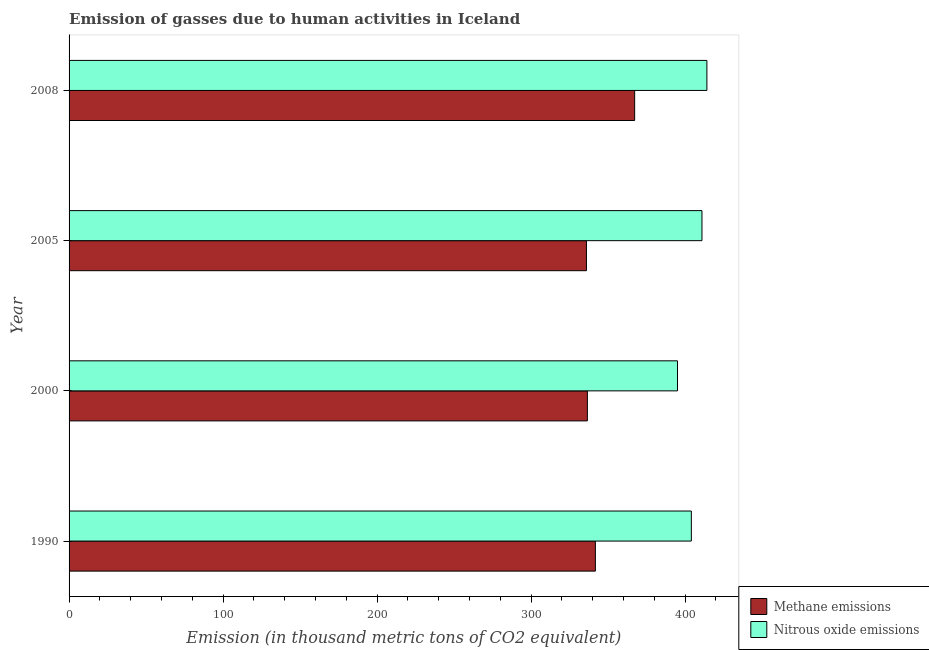Are the number of bars per tick equal to the number of legend labels?
Your answer should be very brief. Yes. Are the number of bars on each tick of the Y-axis equal?
Provide a short and direct response. Yes. How many bars are there on the 4th tick from the top?
Keep it short and to the point. 2. How many bars are there on the 3rd tick from the bottom?
Provide a short and direct response. 2. In how many cases, is the number of bars for a given year not equal to the number of legend labels?
Provide a succinct answer. 0. What is the amount of methane emissions in 1990?
Provide a succinct answer. 341.7. Across all years, what is the maximum amount of nitrous oxide emissions?
Ensure brevity in your answer.  414.1. Across all years, what is the minimum amount of methane emissions?
Offer a terse response. 335.9. In which year was the amount of methane emissions minimum?
Your response must be concise. 2005. What is the total amount of nitrous oxide emissions in the graph?
Keep it short and to the point. 1624. What is the difference between the amount of nitrous oxide emissions in 1990 and that in 2008?
Give a very brief answer. -10.1. What is the difference between the amount of methane emissions in 2000 and the amount of nitrous oxide emissions in 1990?
Ensure brevity in your answer.  -67.5. What is the average amount of nitrous oxide emissions per year?
Provide a succinct answer. 406. In the year 2005, what is the difference between the amount of nitrous oxide emissions and amount of methane emissions?
Give a very brief answer. 75. What is the ratio of the amount of methane emissions in 2000 to that in 2005?
Give a very brief answer. 1. Is the amount of methane emissions in 2005 less than that in 2008?
Make the answer very short. Yes. Is the difference between the amount of nitrous oxide emissions in 2000 and 2008 greater than the difference between the amount of methane emissions in 2000 and 2008?
Your response must be concise. Yes. What is the difference between the highest and the lowest amount of nitrous oxide emissions?
Your response must be concise. 19.1. What does the 1st bar from the top in 2005 represents?
Make the answer very short. Nitrous oxide emissions. What does the 2nd bar from the bottom in 2005 represents?
Make the answer very short. Nitrous oxide emissions. How many years are there in the graph?
Your answer should be very brief. 4. Are the values on the major ticks of X-axis written in scientific E-notation?
Your answer should be compact. No. Does the graph contain any zero values?
Keep it short and to the point. No. What is the title of the graph?
Make the answer very short. Emission of gasses due to human activities in Iceland. Does "Private credit bureau" appear as one of the legend labels in the graph?
Offer a very short reply. No. What is the label or title of the X-axis?
Your answer should be compact. Emission (in thousand metric tons of CO2 equivalent). What is the Emission (in thousand metric tons of CO2 equivalent) of Methane emissions in 1990?
Provide a short and direct response. 341.7. What is the Emission (in thousand metric tons of CO2 equivalent) of Nitrous oxide emissions in 1990?
Provide a succinct answer. 404. What is the Emission (in thousand metric tons of CO2 equivalent) of Methane emissions in 2000?
Keep it short and to the point. 336.5. What is the Emission (in thousand metric tons of CO2 equivalent) in Nitrous oxide emissions in 2000?
Ensure brevity in your answer.  395. What is the Emission (in thousand metric tons of CO2 equivalent) of Methane emissions in 2005?
Ensure brevity in your answer.  335.9. What is the Emission (in thousand metric tons of CO2 equivalent) in Nitrous oxide emissions in 2005?
Make the answer very short. 410.9. What is the Emission (in thousand metric tons of CO2 equivalent) in Methane emissions in 2008?
Provide a short and direct response. 367.2. What is the Emission (in thousand metric tons of CO2 equivalent) of Nitrous oxide emissions in 2008?
Provide a succinct answer. 414.1. Across all years, what is the maximum Emission (in thousand metric tons of CO2 equivalent) in Methane emissions?
Offer a very short reply. 367.2. Across all years, what is the maximum Emission (in thousand metric tons of CO2 equivalent) of Nitrous oxide emissions?
Your response must be concise. 414.1. Across all years, what is the minimum Emission (in thousand metric tons of CO2 equivalent) of Methane emissions?
Make the answer very short. 335.9. Across all years, what is the minimum Emission (in thousand metric tons of CO2 equivalent) of Nitrous oxide emissions?
Offer a very short reply. 395. What is the total Emission (in thousand metric tons of CO2 equivalent) in Methane emissions in the graph?
Your answer should be very brief. 1381.3. What is the total Emission (in thousand metric tons of CO2 equivalent) in Nitrous oxide emissions in the graph?
Keep it short and to the point. 1624. What is the difference between the Emission (in thousand metric tons of CO2 equivalent) in Nitrous oxide emissions in 1990 and that in 2000?
Offer a very short reply. 9. What is the difference between the Emission (in thousand metric tons of CO2 equivalent) of Methane emissions in 1990 and that in 2008?
Ensure brevity in your answer.  -25.5. What is the difference between the Emission (in thousand metric tons of CO2 equivalent) of Nitrous oxide emissions in 1990 and that in 2008?
Offer a very short reply. -10.1. What is the difference between the Emission (in thousand metric tons of CO2 equivalent) in Methane emissions in 2000 and that in 2005?
Your answer should be very brief. 0.6. What is the difference between the Emission (in thousand metric tons of CO2 equivalent) of Nitrous oxide emissions in 2000 and that in 2005?
Offer a very short reply. -15.9. What is the difference between the Emission (in thousand metric tons of CO2 equivalent) in Methane emissions in 2000 and that in 2008?
Provide a short and direct response. -30.7. What is the difference between the Emission (in thousand metric tons of CO2 equivalent) in Nitrous oxide emissions in 2000 and that in 2008?
Provide a succinct answer. -19.1. What is the difference between the Emission (in thousand metric tons of CO2 equivalent) in Methane emissions in 2005 and that in 2008?
Offer a terse response. -31.3. What is the difference between the Emission (in thousand metric tons of CO2 equivalent) in Methane emissions in 1990 and the Emission (in thousand metric tons of CO2 equivalent) in Nitrous oxide emissions in 2000?
Offer a terse response. -53.3. What is the difference between the Emission (in thousand metric tons of CO2 equivalent) of Methane emissions in 1990 and the Emission (in thousand metric tons of CO2 equivalent) of Nitrous oxide emissions in 2005?
Offer a terse response. -69.2. What is the difference between the Emission (in thousand metric tons of CO2 equivalent) of Methane emissions in 1990 and the Emission (in thousand metric tons of CO2 equivalent) of Nitrous oxide emissions in 2008?
Offer a terse response. -72.4. What is the difference between the Emission (in thousand metric tons of CO2 equivalent) in Methane emissions in 2000 and the Emission (in thousand metric tons of CO2 equivalent) in Nitrous oxide emissions in 2005?
Keep it short and to the point. -74.4. What is the difference between the Emission (in thousand metric tons of CO2 equivalent) in Methane emissions in 2000 and the Emission (in thousand metric tons of CO2 equivalent) in Nitrous oxide emissions in 2008?
Provide a short and direct response. -77.6. What is the difference between the Emission (in thousand metric tons of CO2 equivalent) in Methane emissions in 2005 and the Emission (in thousand metric tons of CO2 equivalent) in Nitrous oxide emissions in 2008?
Keep it short and to the point. -78.2. What is the average Emission (in thousand metric tons of CO2 equivalent) in Methane emissions per year?
Make the answer very short. 345.32. What is the average Emission (in thousand metric tons of CO2 equivalent) in Nitrous oxide emissions per year?
Keep it short and to the point. 406. In the year 1990, what is the difference between the Emission (in thousand metric tons of CO2 equivalent) of Methane emissions and Emission (in thousand metric tons of CO2 equivalent) of Nitrous oxide emissions?
Give a very brief answer. -62.3. In the year 2000, what is the difference between the Emission (in thousand metric tons of CO2 equivalent) of Methane emissions and Emission (in thousand metric tons of CO2 equivalent) of Nitrous oxide emissions?
Provide a succinct answer. -58.5. In the year 2005, what is the difference between the Emission (in thousand metric tons of CO2 equivalent) in Methane emissions and Emission (in thousand metric tons of CO2 equivalent) in Nitrous oxide emissions?
Your answer should be compact. -75. In the year 2008, what is the difference between the Emission (in thousand metric tons of CO2 equivalent) in Methane emissions and Emission (in thousand metric tons of CO2 equivalent) in Nitrous oxide emissions?
Offer a terse response. -46.9. What is the ratio of the Emission (in thousand metric tons of CO2 equivalent) of Methane emissions in 1990 to that in 2000?
Offer a terse response. 1.02. What is the ratio of the Emission (in thousand metric tons of CO2 equivalent) of Nitrous oxide emissions in 1990 to that in 2000?
Provide a short and direct response. 1.02. What is the ratio of the Emission (in thousand metric tons of CO2 equivalent) in Methane emissions in 1990 to that in 2005?
Keep it short and to the point. 1.02. What is the ratio of the Emission (in thousand metric tons of CO2 equivalent) of Nitrous oxide emissions in 1990 to that in 2005?
Your answer should be compact. 0.98. What is the ratio of the Emission (in thousand metric tons of CO2 equivalent) of Methane emissions in 1990 to that in 2008?
Make the answer very short. 0.93. What is the ratio of the Emission (in thousand metric tons of CO2 equivalent) of Nitrous oxide emissions in 1990 to that in 2008?
Your answer should be very brief. 0.98. What is the ratio of the Emission (in thousand metric tons of CO2 equivalent) in Methane emissions in 2000 to that in 2005?
Your answer should be very brief. 1. What is the ratio of the Emission (in thousand metric tons of CO2 equivalent) in Nitrous oxide emissions in 2000 to that in 2005?
Offer a very short reply. 0.96. What is the ratio of the Emission (in thousand metric tons of CO2 equivalent) in Methane emissions in 2000 to that in 2008?
Make the answer very short. 0.92. What is the ratio of the Emission (in thousand metric tons of CO2 equivalent) in Nitrous oxide emissions in 2000 to that in 2008?
Your answer should be very brief. 0.95. What is the ratio of the Emission (in thousand metric tons of CO2 equivalent) of Methane emissions in 2005 to that in 2008?
Ensure brevity in your answer.  0.91. What is the difference between the highest and the second highest Emission (in thousand metric tons of CO2 equivalent) in Methane emissions?
Offer a very short reply. 25.5. What is the difference between the highest and the second highest Emission (in thousand metric tons of CO2 equivalent) in Nitrous oxide emissions?
Ensure brevity in your answer.  3.2. What is the difference between the highest and the lowest Emission (in thousand metric tons of CO2 equivalent) of Methane emissions?
Give a very brief answer. 31.3. 